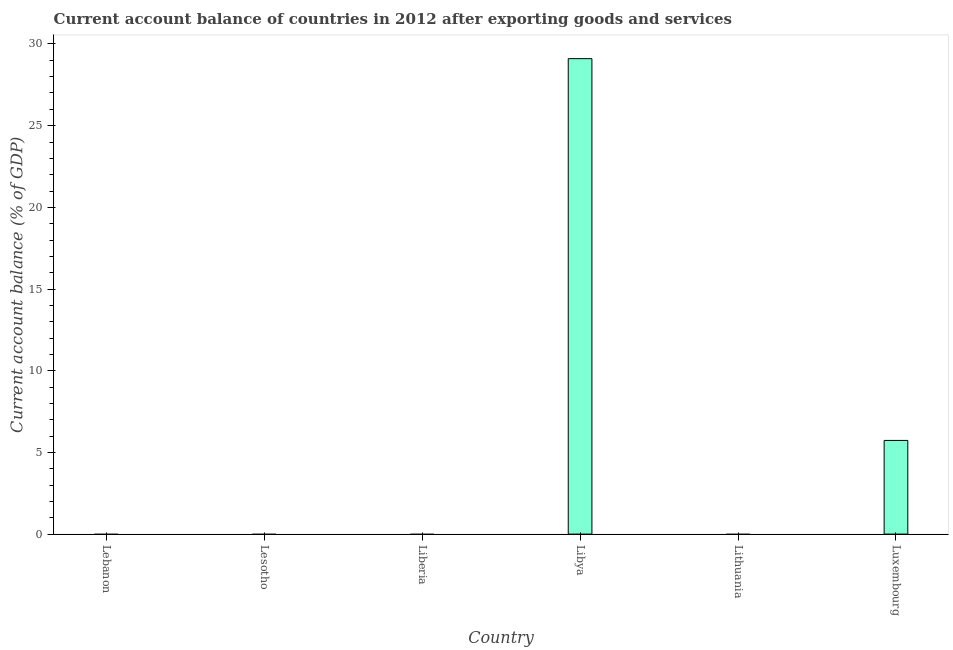Does the graph contain grids?
Your answer should be compact. No. What is the title of the graph?
Ensure brevity in your answer.  Current account balance of countries in 2012 after exporting goods and services. What is the label or title of the Y-axis?
Your answer should be compact. Current account balance (% of GDP). What is the current account balance in Libya?
Provide a succinct answer. 29.1. Across all countries, what is the maximum current account balance?
Keep it short and to the point. 29.1. In which country was the current account balance maximum?
Keep it short and to the point. Libya. What is the sum of the current account balance?
Your answer should be compact. 34.84. What is the difference between the current account balance in Libya and Luxembourg?
Keep it short and to the point. 23.37. What is the average current account balance per country?
Your response must be concise. 5.81. What is the difference between the highest and the lowest current account balance?
Your answer should be very brief. 29.1. In how many countries, is the current account balance greater than the average current account balance taken over all countries?
Offer a terse response. 1. Are all the bars in the graph horizontal?
Your answer should be compact. No. How many countries are there in the graph?
Provide a short and direct response. 6. What is the Current account balance (% of GDP) in Lebanon?
Provide a short and direct response. 0. What is the Current account balance (% of GDP) of Lesotho?
Your response must be concise. 0. What is the Current account balance (% of GDP) in Liberia?
Your answer should be compact. 0. What is the Current account balance (% of GDP) of Libya?
Ensure brevity in your answer.  29.1. What is the Current account balance (% of GDP) in Luxembourg?
Your answer should be compact. 5.73. What is the difference between the Current account balance (% of GDP) in Libya and Luxembourg?
Offer a terse response. 23.37. What is the ratio of the Current account balance (% of GDP) in Libya to that in Luxembourg?
Your response must be concise. 5.08. 